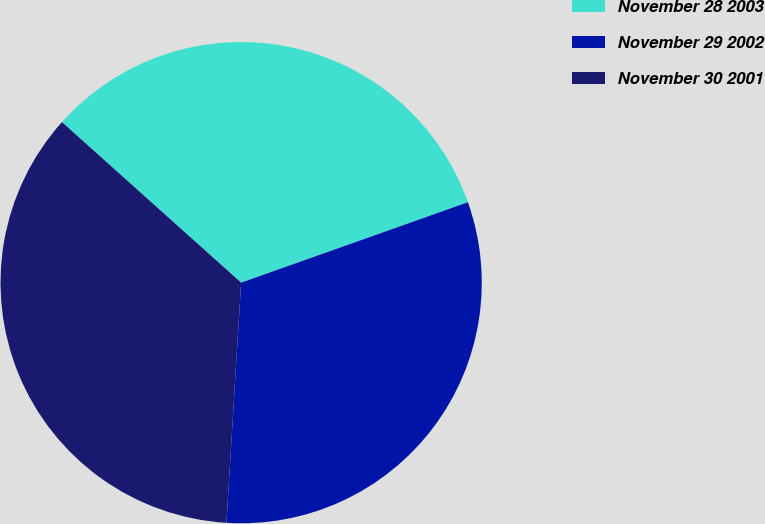Convert chart. <chart><loc_0><loc_0><loc_500><loc_500><pie_chart><fcel>November 28 2003<fcel>November 29 2002<fcel>November 30 2001<nl><fcel>32.95%<fcel>31.4%<fcel>35.65%<nl></chart> 